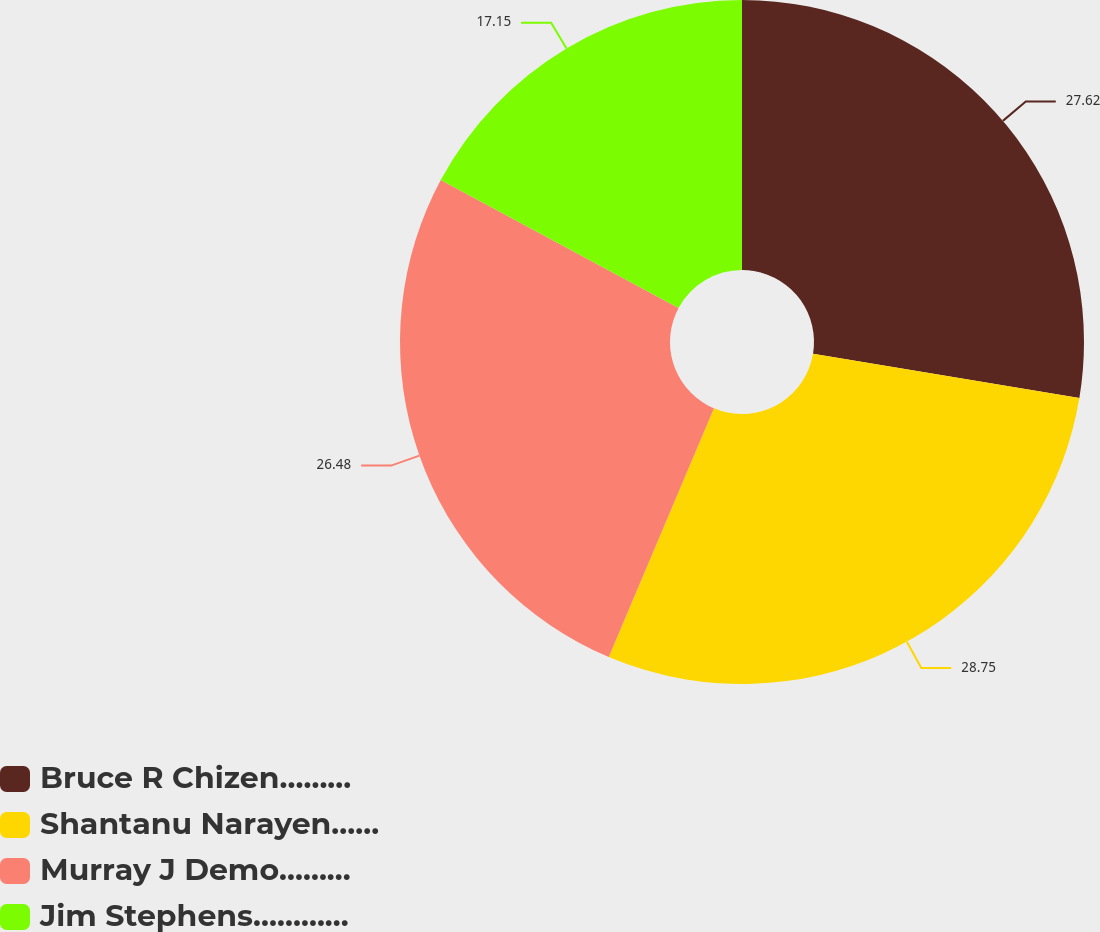Convert chart to OTSL. <chart><loc_0><loc_0><loc_500><loc_500><pie_chart><fcel>Bruce R Chizen………<fcel>Shantanu Narayen……<fcel>Murray J Demo………<fcel>Jim Stephens…………<nl><fcel>27.62%<fcel>28.75%<fcel>26.48%<fcel>17.15%<nl></chart> 